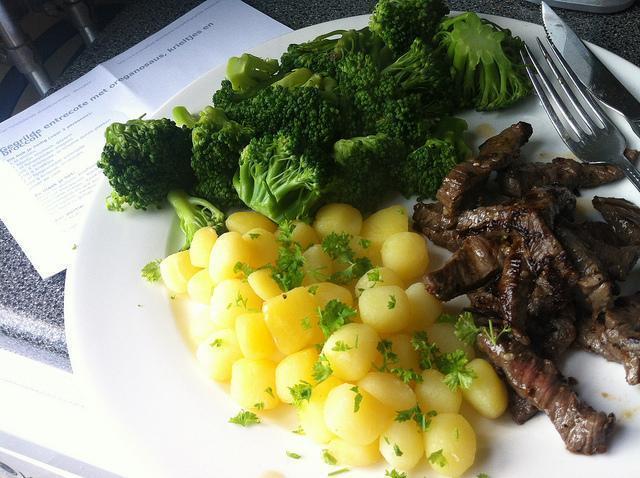How many broccolis are in the photo?
Give a very brief answer. 6. How many people are holding a remote controller?
Give a very brief answer. 0. 